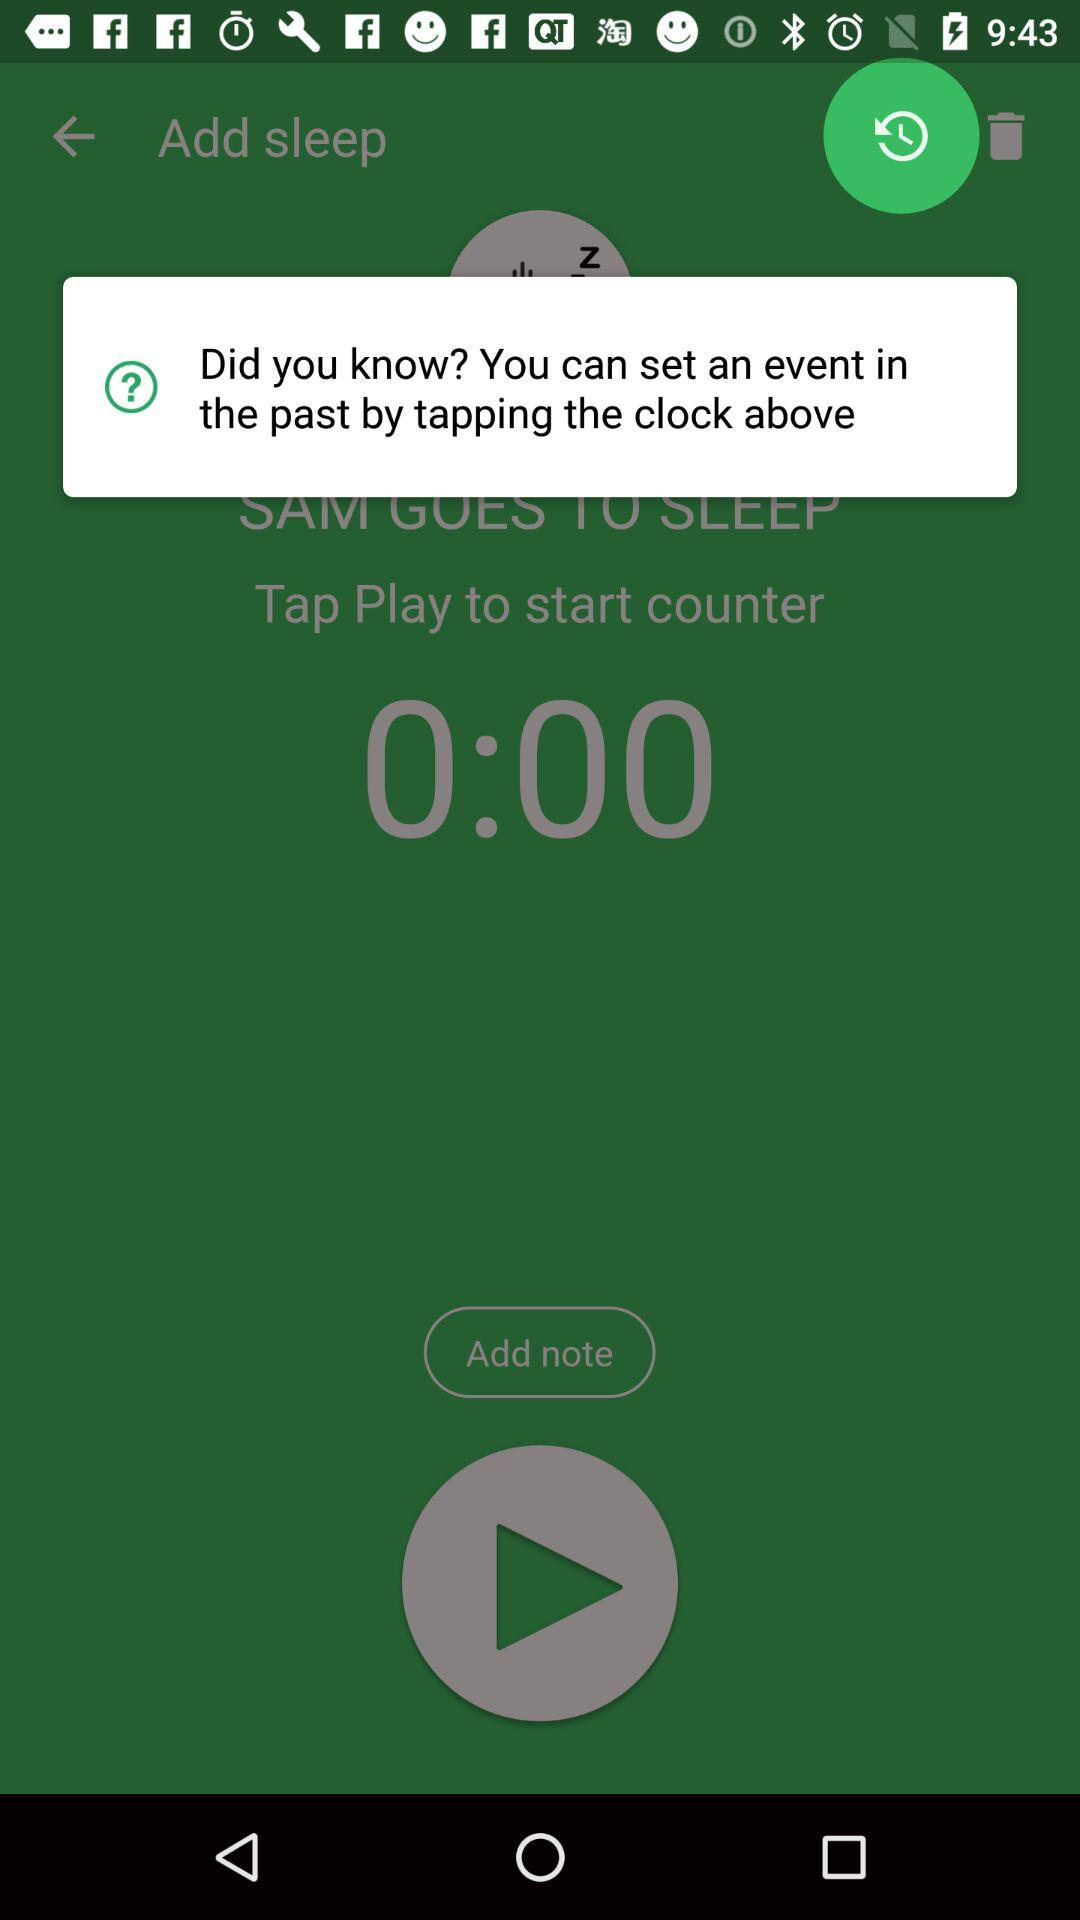How many seconds does the timer have?
Answer the question using a single word or phrase. 0 